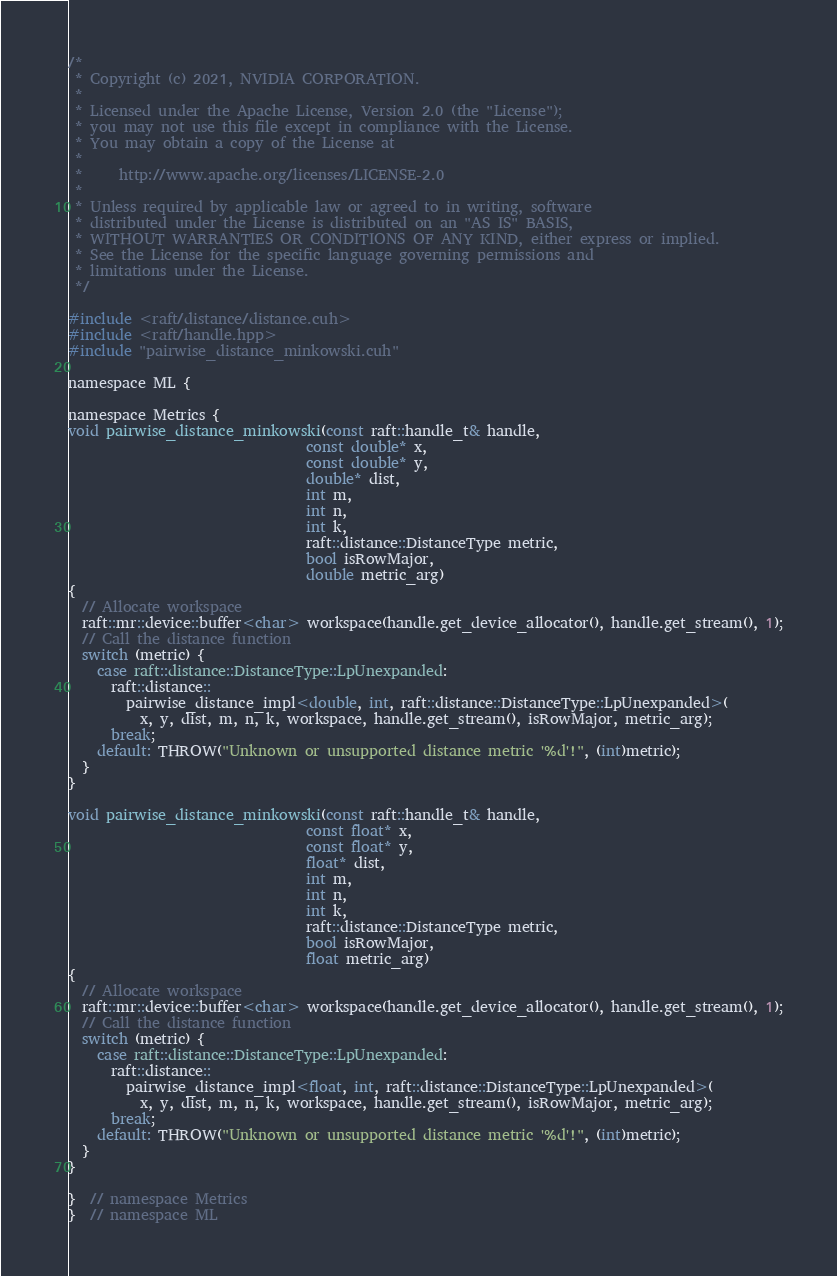<code> <loc_0><loc_0><loc_500><loc_500><_Cuda_>
/*
 * Copyright (c) 2021, NVIDIA CORPORATION.
 *
 * Licensed under the Apache License, Version 2.0 (the "License");
 * you may not use this file except in compliance with the License.
 * You may obtain a copy of the License at
 *
 *     http://www.apache.org/licenses/LICENSE-2.0
 *
 * Unless required by applicable law or agreed to in writing, software
 * distributed under the License is distributed on an "AS IS" BASIS,
 * WITHOUT WARRANTIES OR CONDITIONS OF ANY KIND, either express or implied.
 * See the License for the specific language governing permissions and
 * limitations under the License.
 */

#include <raft/distance/distance.cuh>
#include <raft/handle.hpp>
#include "pairwise_distance_minkowski.cuh"

namespace ML {

namespace Metrics {
void pairwise_distance_minkowski(const raft::handle_t& handle,
                                 const double* x,
                                 const double* y,
                                 double* dist,
                                 int m,
                                 int n,
                                 int k,
                                 raft::distance::DistanceType metric,
                                 bool isRowMajor,
                                 double metric_arg)
{
  // Allocate workspace
  raft::mr::device::buffer<char> workspace(handle.get_device_allocator(), handle.get_stream(), 1);
  // Call the distance function
  switch (metric) {
    case raft::distance::DistanceType::LpUnexpanded:
      raft::distance::
        pairwise_distance_impl<double, int, raft::distance::DistanceType::LpUnexpanded>(
          x, y, dist, m, n, k, workspace, handle.get_stream(), isRowMajor, metric_arg);
      break;
    default: THROW("Unknown or unsupported distance metric '%d'!", (int)metric);
  }
}

void pairwise_distance_minkowski(const raft::handle_t& handle,
                                 const float* x,
                                 const float* y,
                                 float* dist,
                                 int m,
                                 int n,
                                 int k,
                                 raft::distance::DistanceType metric,
                                 bool isRowMajor,
                                 float metric_arg)
{
  // Allocate workspace
  raft::mr::device::buffer<char> workspace(handle.get_device_allocator(), handle.get_stream(), 1);
  // Call the distance function
  switch (metric) {
    case raft::distance::DistanceType::LpUnexpanded:
      raft::distance::
        pairwise_distance_impl<float, int, raft::distance::DistanceType::LpUnexpanded>(
          x, y, dist, m, n, k, workspace, handle.get_stream(), isRowMajor, metric_arg);
      break;
    default: THROW("Unknown or unsupported distance metric '%d'!", (int)metric);
  }
}

}  // namespace Metrics
}  // namespace ML
</code> 